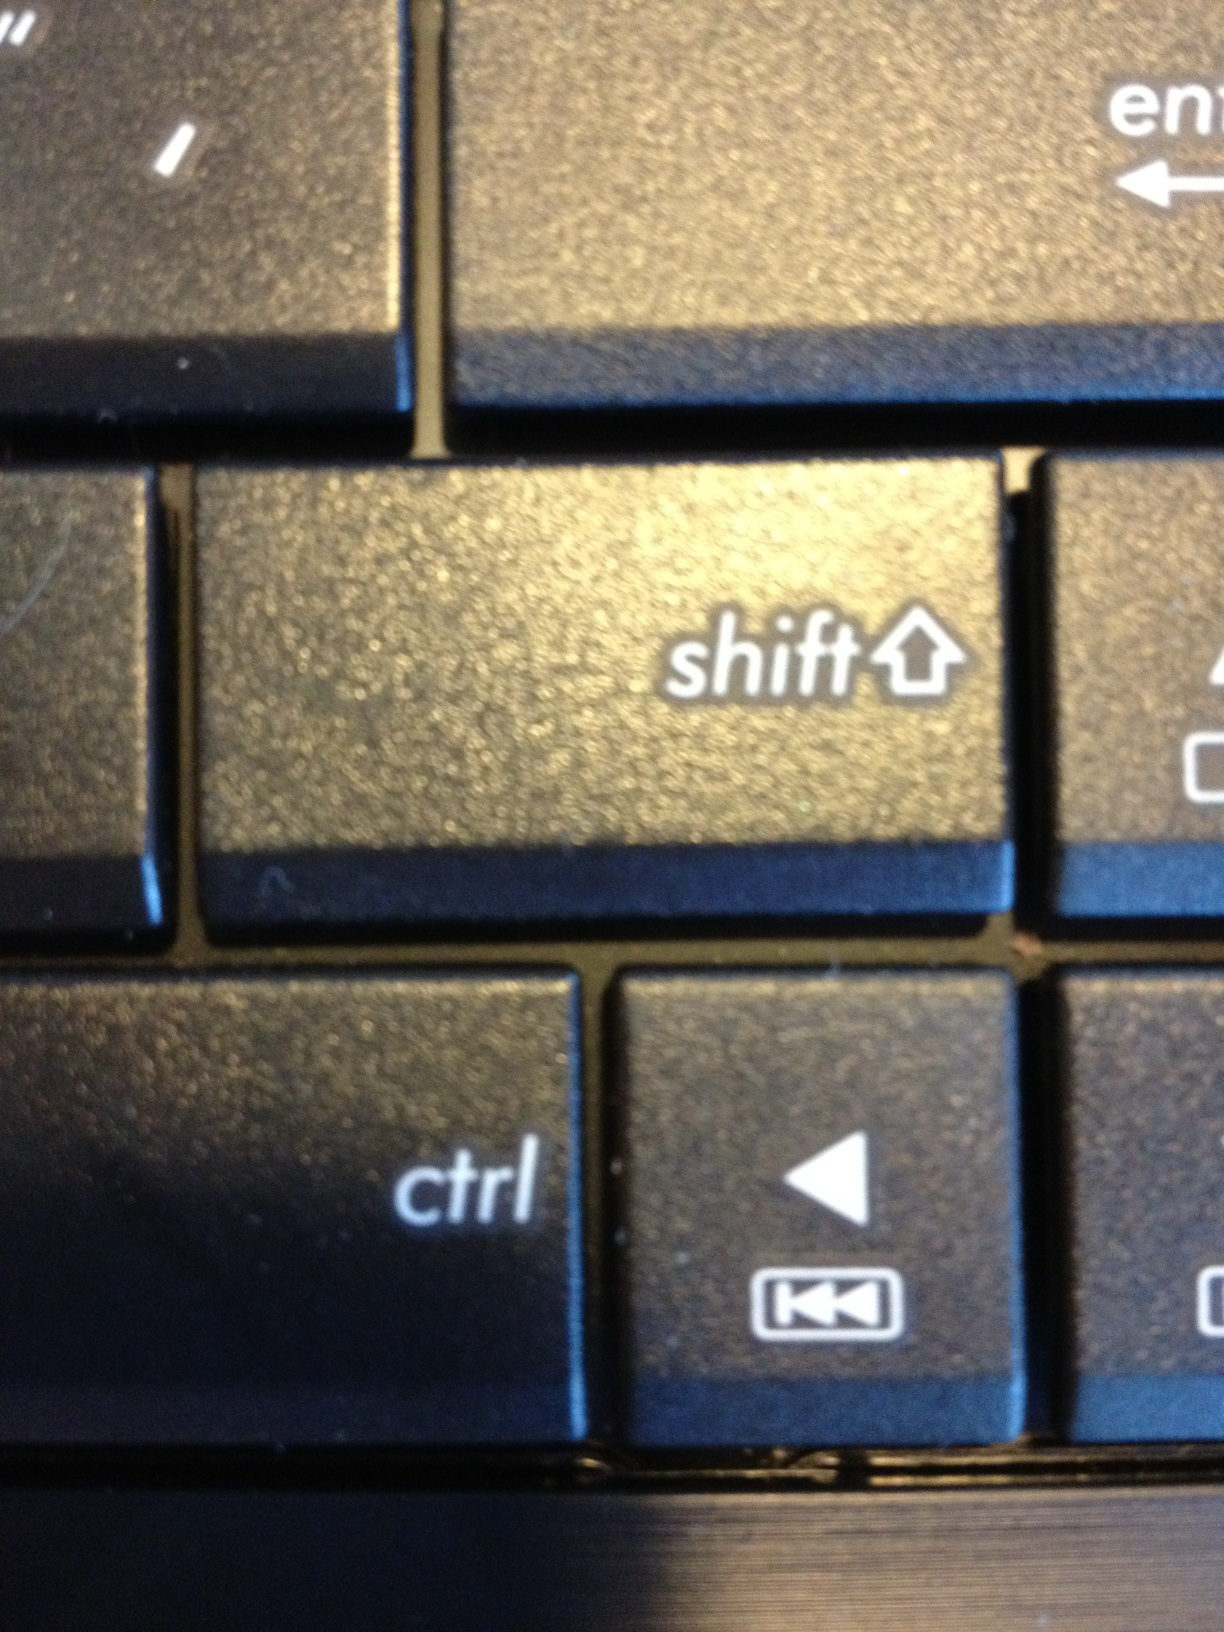What kind of functions do these keys perform? The 'Shift' key is typically used to type uppercase letters or alternative characters located at the top of other keys. The 'Ctrl' key is often used in combination with other keys to perform various shortcut commands, like 'Ctrl+C' to copy. The 'Enter' key is used to execute commands or enter information into fields, and the 'Backtrack' navigation key is commonly used to go back to a previous page or to navigate within software applications or web browsers. 